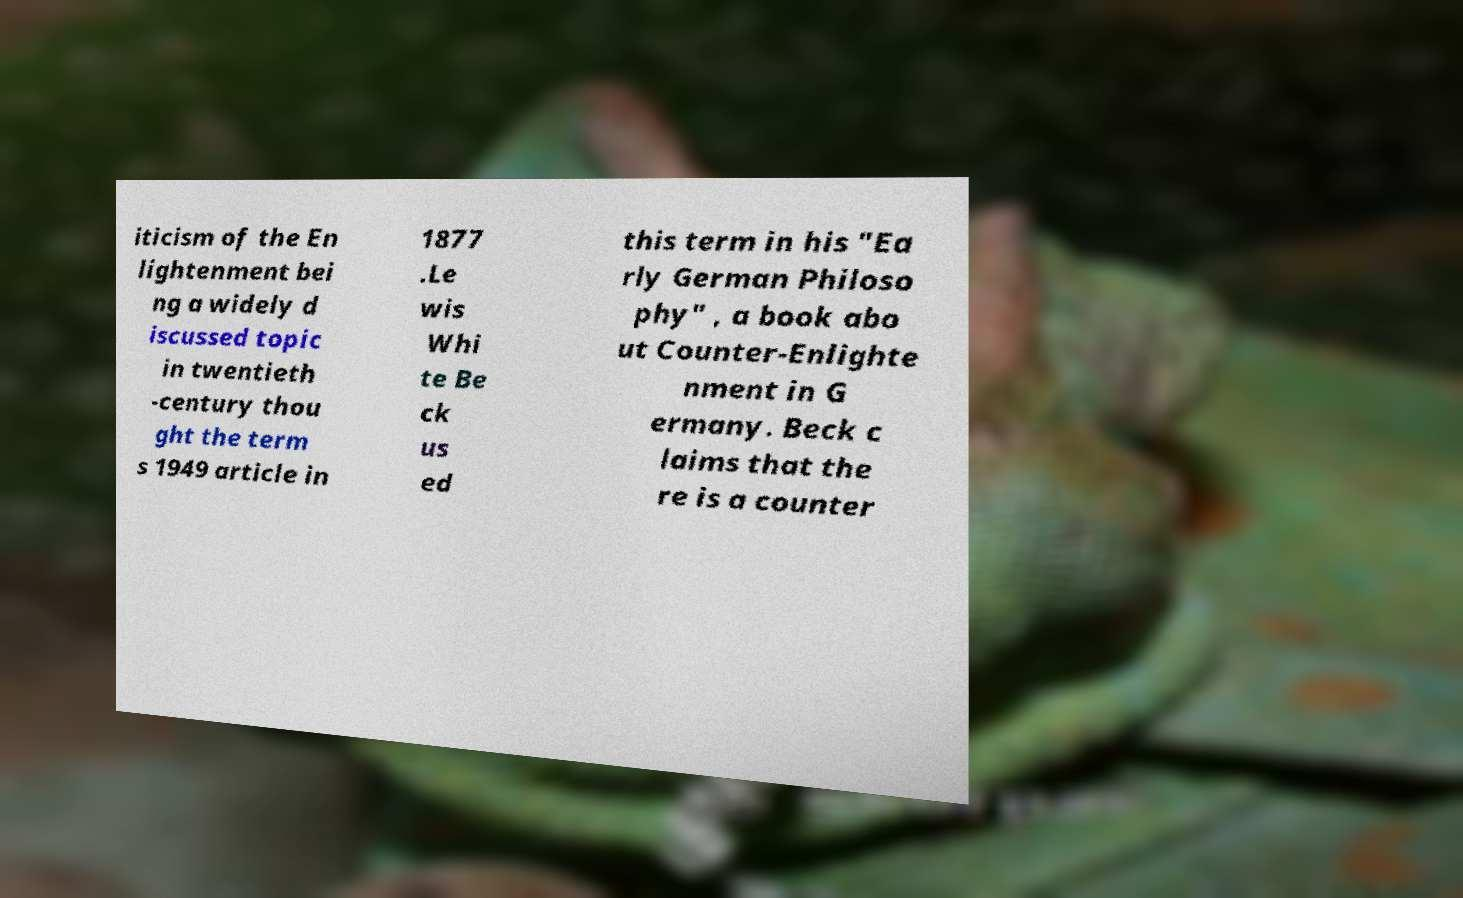Can you read and provide the text displayed in the image?This photo seems to have some interesting text. Can you extract and type it out for me? iticism of the En lightenment bei ng a widely d iscussed topic in twentieth -century thou ght the term s 1949 article in 1877 .Le wis Whi te Be ck us ed this term in his "Ea rly German Philoso phy" , a book abo ut Counter-Enlighte nment in G ermany. Beck c laims that the re is a counter 